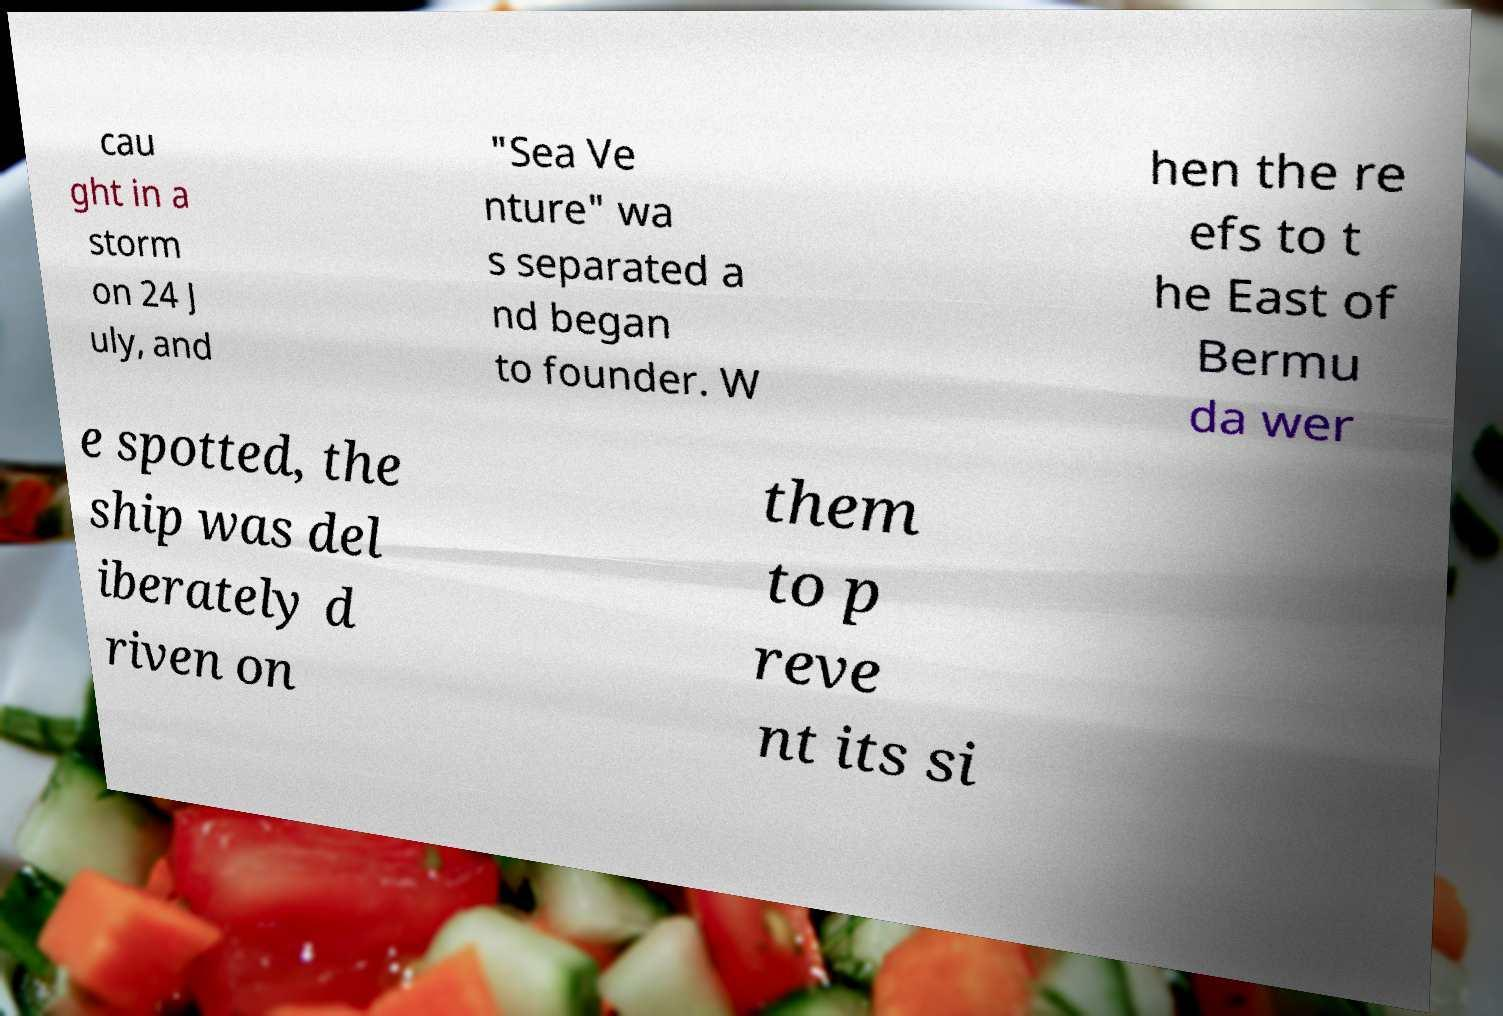Please read and relay the text visible in this image. What does it say? cau ght in a storm on 24 J uly, and "Sea Ve nture" wa s separated a nd began to founder. W hen the re efs to t he East of Bermu da wer e spotted, the ship was del iberately d riven on them to p reve nt its si 